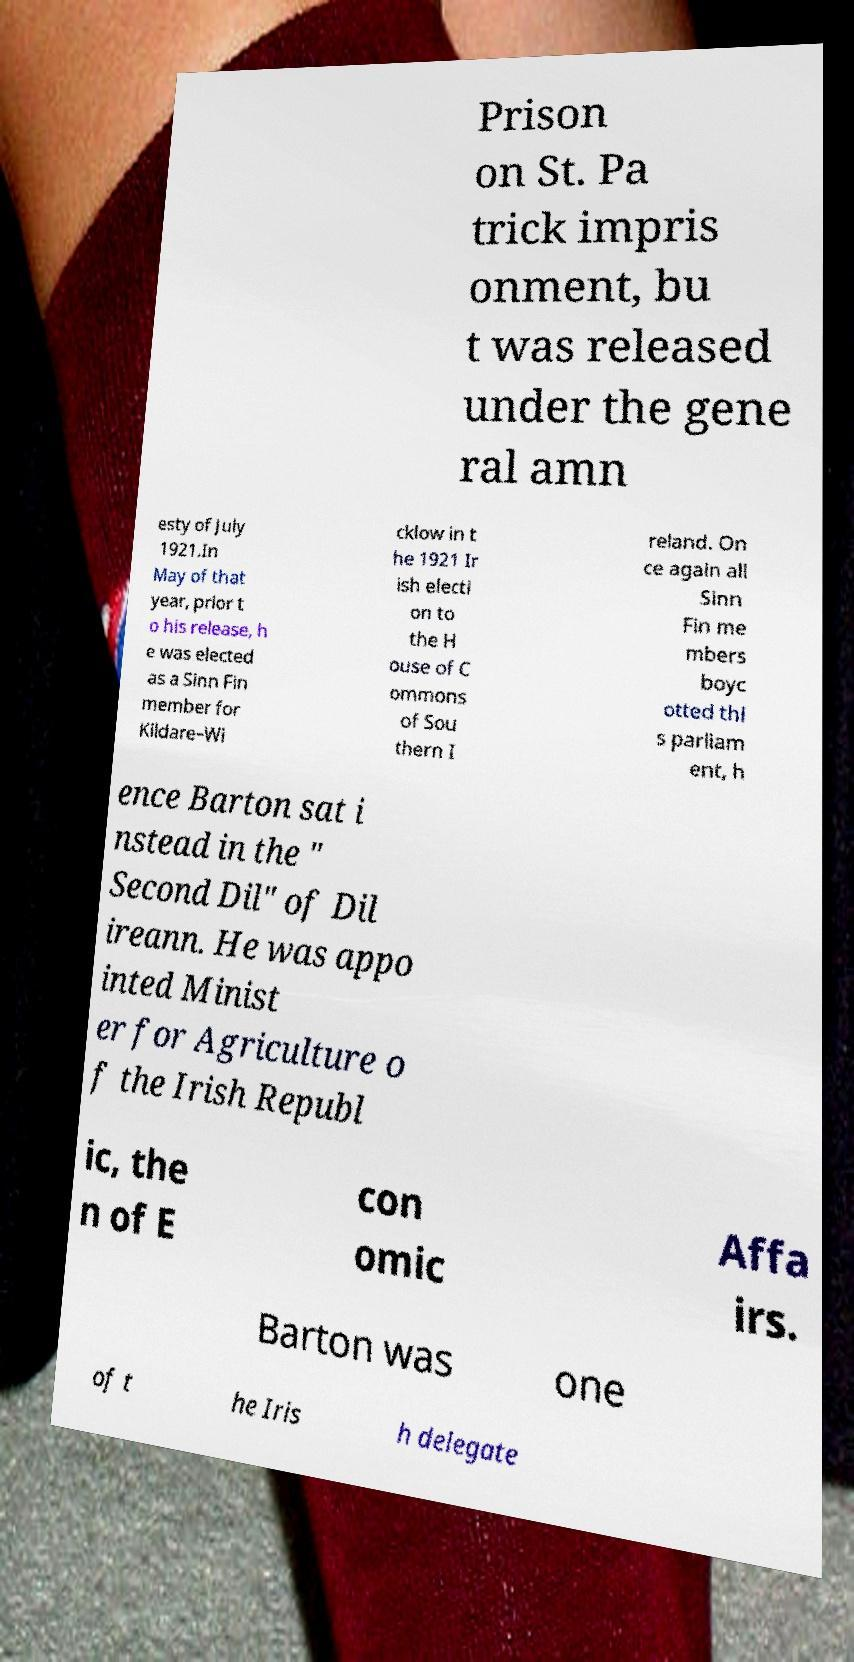Could you extract and type out the text from this image? Prison on St. Pa trick impris onment, bu t was released under the gene ral amn esty of July 1921.In May of that year, prior t o his release, h e was elected as a Sinn Fin member for Kildare–Wi cklow in t he 1921 Ir ish electi on to the H ouse of C ommons of Sou thern I reland. On ce again all Sinn Fin me mbers boyc otted thi s parliam ent, h ence Barton sat i nstead in the " Second Dil" of Dil ireann. He was appo inted Minist er for Agriculture o f the Irish Republ ic, the n of E con omic Affa irs. Barton was one of t he Iris h delegate 